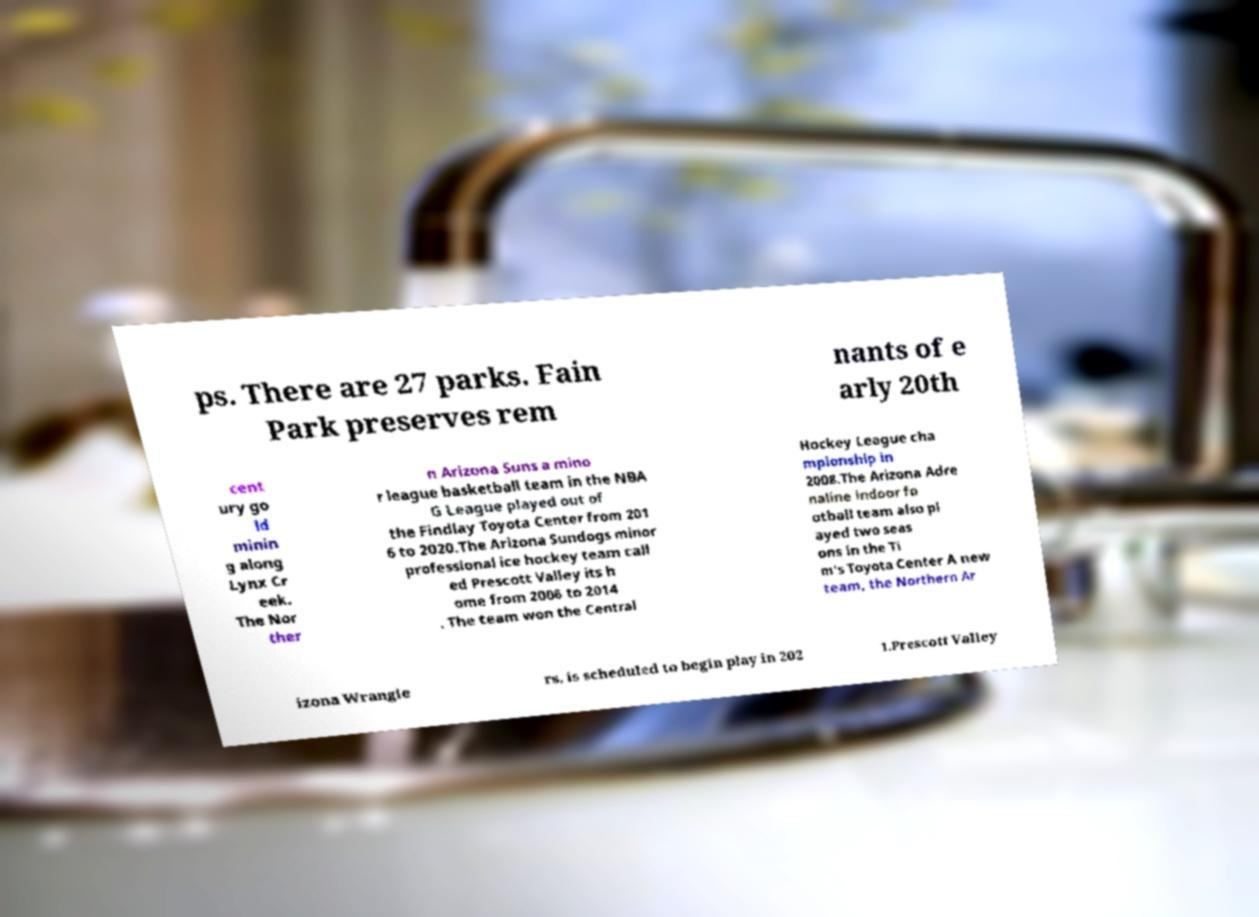Can you accurately transcribe the text from the provided image for me? ps. There are 27 parks. Fain Park preserves rem nants of e arly 20th cent ury go ld minin g along Lynx Cr eek. The Nor ther n Arizona Suns a mino r league basketball team in the NBA G League played out of the Findlay Toyota Center from 201 6 to 2020.The Arizona Sundogs minor professional ice hockey team call ed Prescott Valley its h ome from 2006 to 2014 . The team won the Central Hockey League cha mpionship in 2008.The Arizona Adre naline indoor fo otball team also pl ayed two seas ons in the Ti m's Toyota Center A new team, the Northern Ar izona Wrangle rs, is scheduled to begin play in 202 1.Prescott Valley 